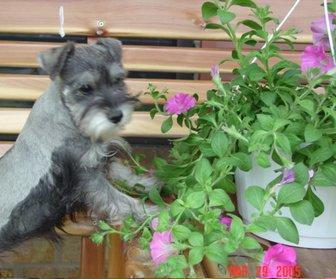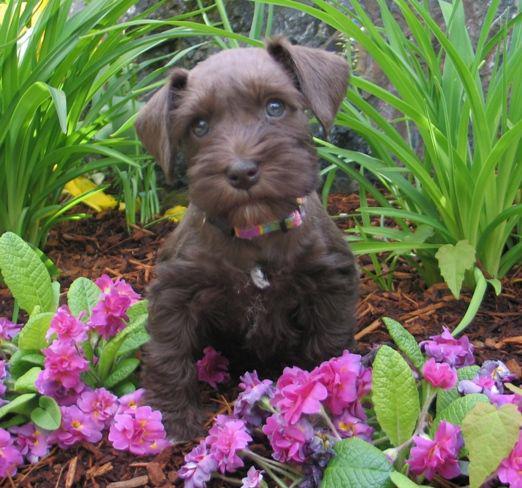The first image is the image on the left, the second image is the image on the right. Examine the images to the left and right. Is the description "An image contains at least three dogs." accurate? Answer yes or no. No. The first image is the image on the left, the second image is the image on the right. Analyze the images presented: Is the assertion "There are at most two dogs." valid? Answer yes or no. Yes. 